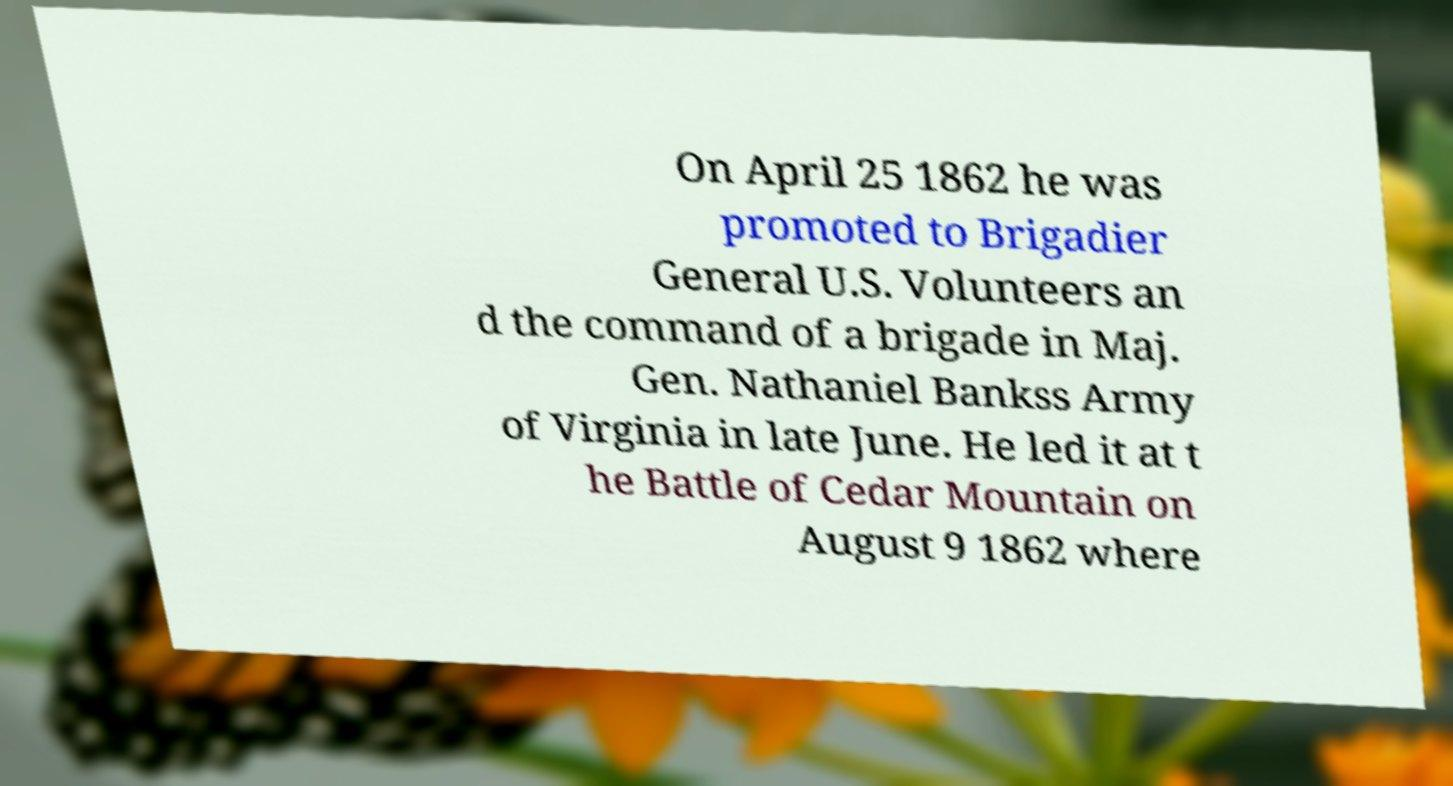Could you assist in decoding the text presented in this image and type it out clearly? On April 25 1862 he was promoted to Brigadier General U.S. Volunteers an d the command of a brigade in Maj. Gen. Nathaniel Bankss Army of Virginia in late June. He led it at t he Battle of Cedar Mountain on August 9 1862 where 